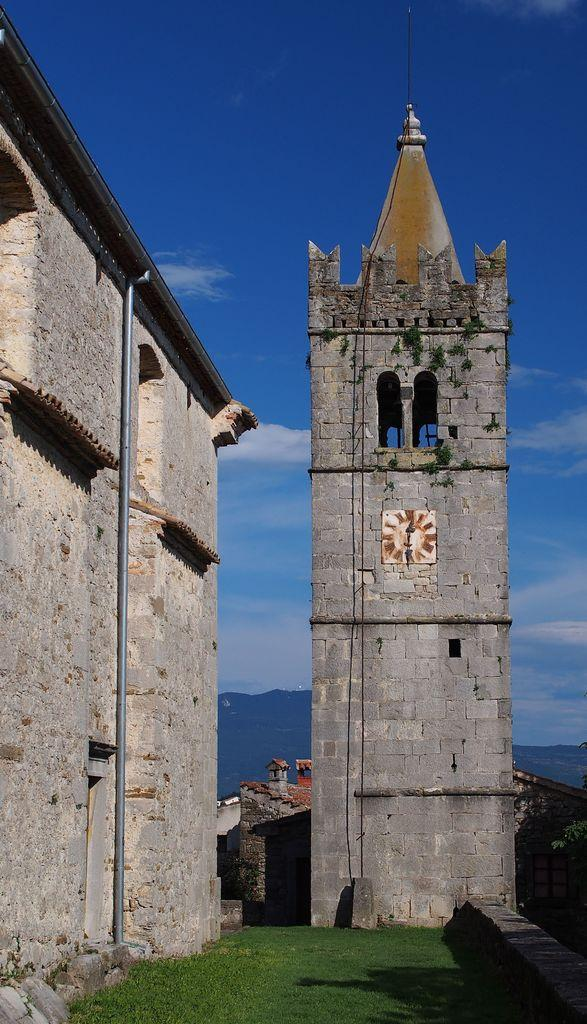What type of structure is in the image? There is a castle in the image. Where is the castle located? The castle is on a grassland. What can be seen in the background of the image? There is a hill in the background of the image. What is visible above the castle and the grassland? The sky is visible in the image, and clouds are present in the sky. What type of hobbies can be seen being practiced by the icicles in the image? There are no icicles present in the image, so it is not possible to determine what hobbies they might be practicing. 